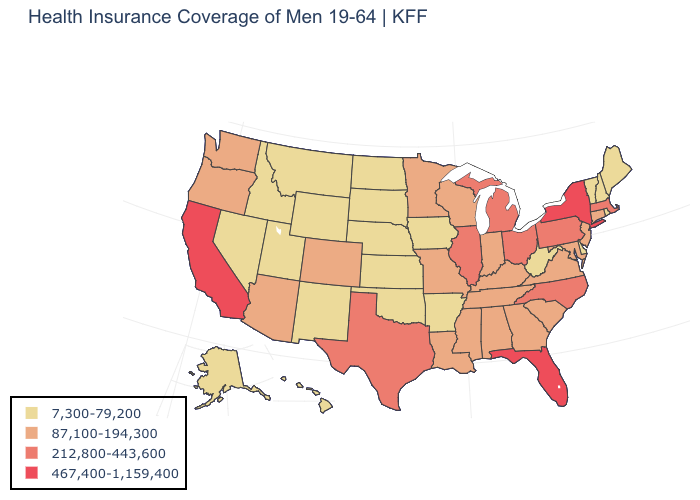What is the highest value in states that border Washington?
Answer briefly. 87,100-194,300. Among the states that border Wisconsin , does Illinois have the highest value?
Answer briefly. Yes. Does the first symbol in the legend represent the smallest category?
Short answer required. Yes. What is the value of Wyoming?
Short answer required. 7,300-79,200. What is the value of Alabama?
Be succinct. 87,100-194,300. Which states have the lowest value in the USA?
Short answer required. Alaska, Arkansas, Delaware, Hawaii, Idaho, Iowa, Kansas, Maine, Montana, Nebraska, Nevada, New Hampshire, New Mexico, North Dakota, Oklahoma, Rhode Island, South Dakota, Utah, Vermont, West Virginia, Wyoming. Name the states that have a value in the range 212,800-443,600?
Keep it brief. Illinois, Massachusetts, Michigan, North Carolina, Ohio, Pennsylvania, Texas. Name the states that have a value in the range 7,300-79,200?
Give a very brief answer. Alaska, Arkansas, Delaware, Hawaii, Idaho, Iowa, Kansas, Maine, Montana, Nebraska, Nevada, New Hampshire, New Mexico, North Dakota, Oklahoma, Rhode Island, South Dakota, Utah, Vermont, West Virginia, Wyoming. Does Massachusetts have the lowest value in the Northeast?
Give a very brief answer. No. Does Minnesota have a lower value than North Dakota?
Be succinct. No. Name the states that have a value in the range 212,800-443,600?
Concise answer only. Illinois, Massachusetts, Michigan, North Carolina, Ohio, Pennsylvania, Texas. What is the value of Texas?
Be succinct. 212,800-443,600. What is the highest value in the South ?
Short answer required. 467,400-1,159,400. Does Vermont have the highest value in the Northeast?
Give a very brief answer. No. What is the lowest value in states that border Kansas?
Quick response, please. 7,300-79,200. 